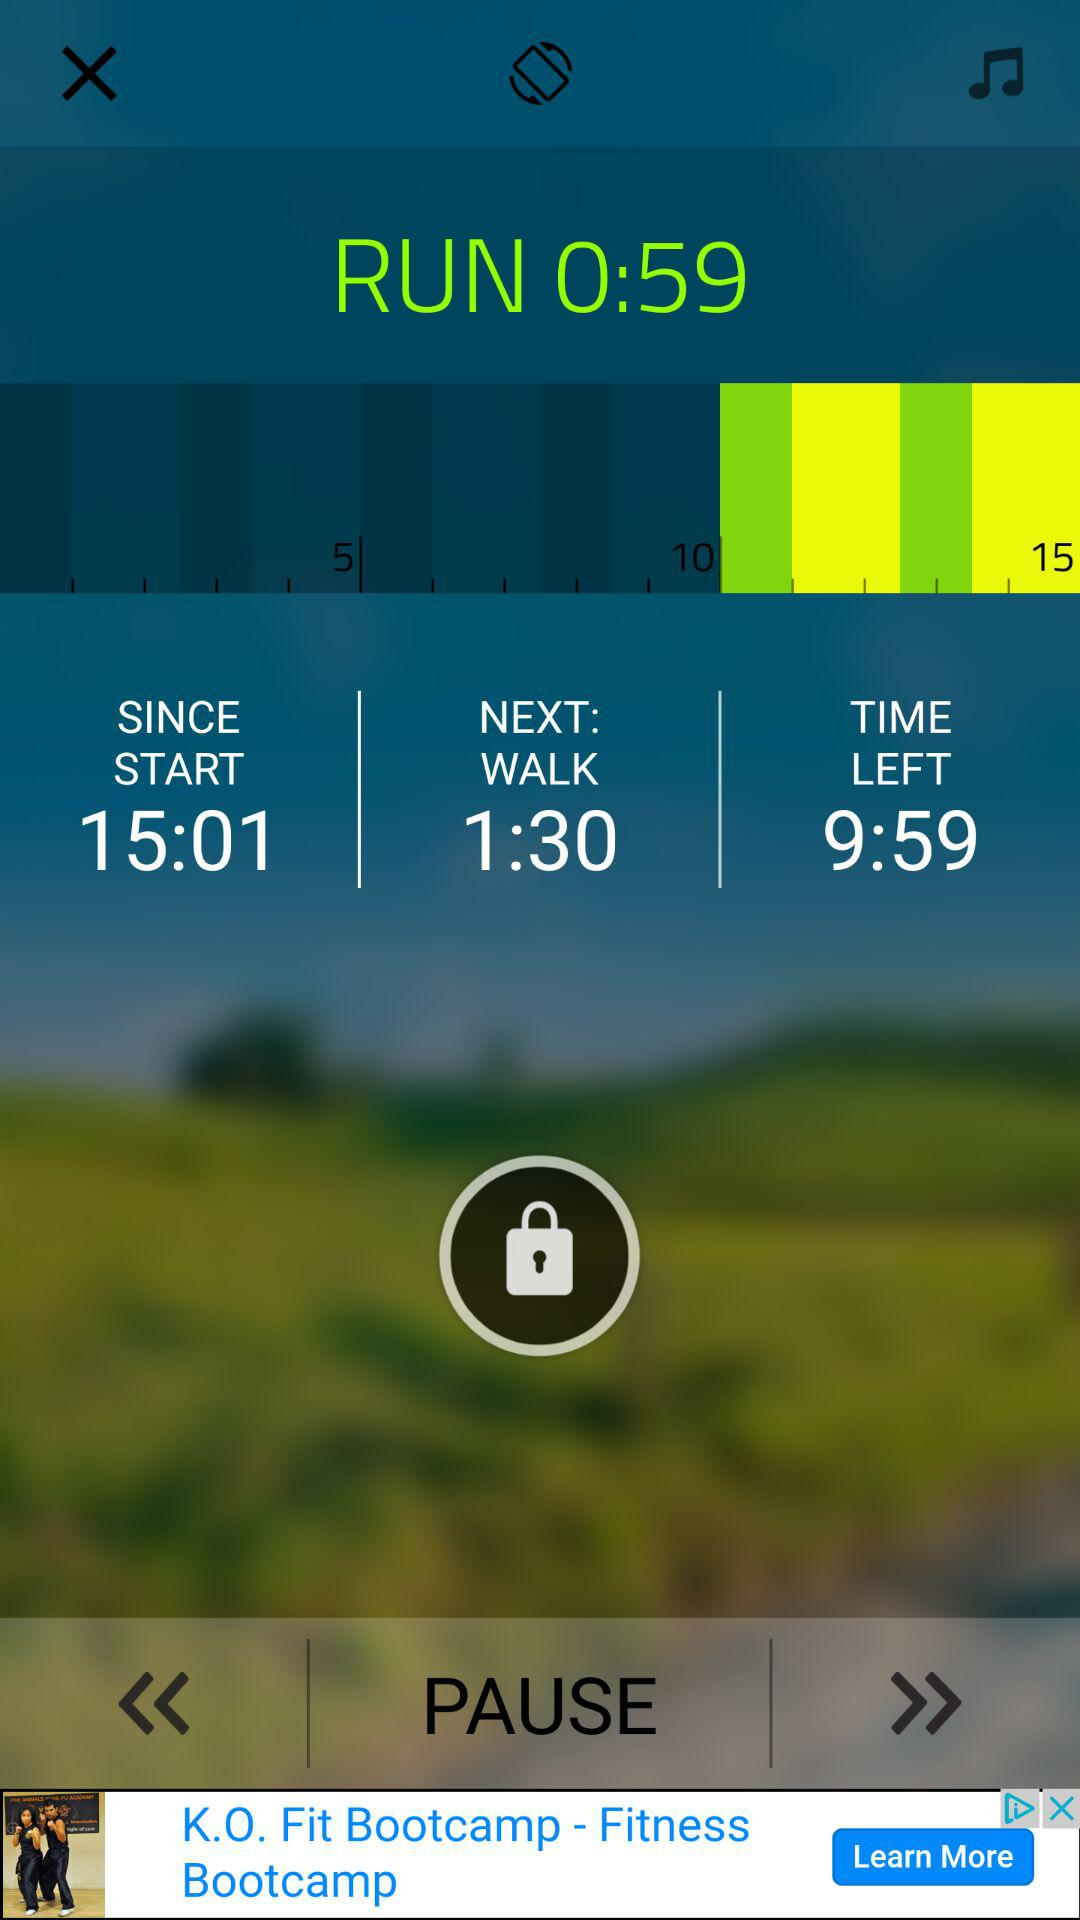What is the duration of the next walk? The duration of the next walk is 1 minute and 30 seconds. 